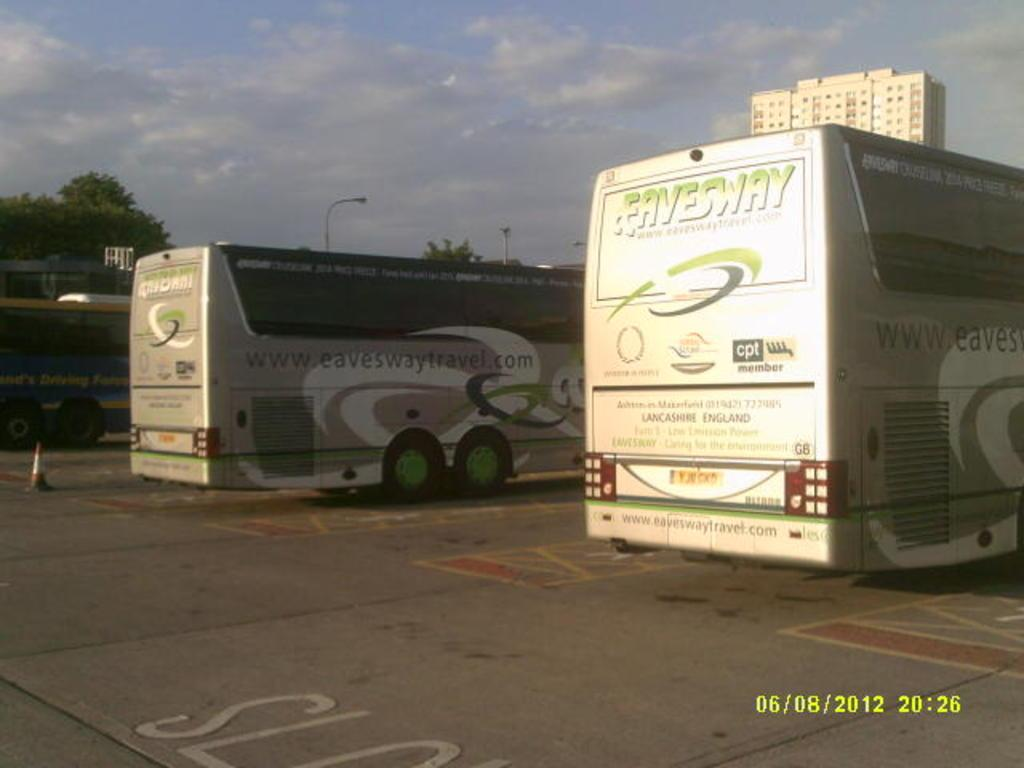What type of vehicles can be seen on the road in the image? There are buses on the road in the image. What object is placed on the road in the image? There is a traffic cone on the road in the image. Can you describe the background of the image? In the background of the image, there are trees, poles, light, a building, and the sky. Is there any information about the date and time in the image? Yes, the date and time are visible in the bottom right corner of the image. What type of drug is being processed in the engine of the bus in the image? There is no mention of drugs or engines in the image; it only shows buses, a traffic cone, and the background elements. 